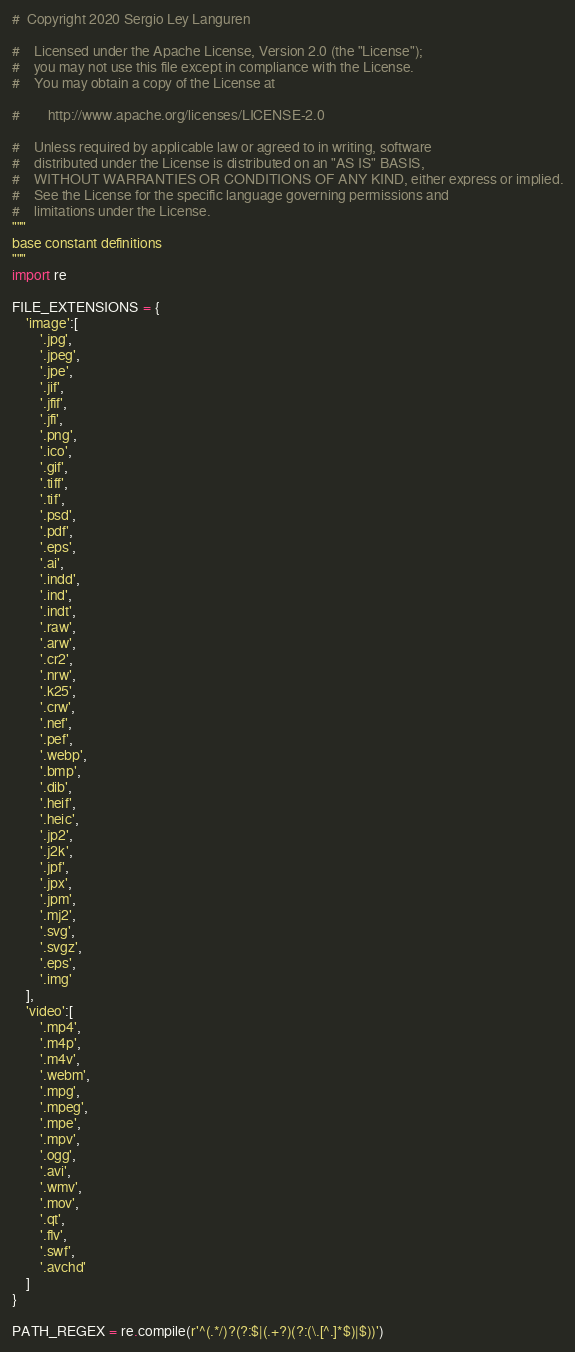<code> <loc_0><loc_0><loc_500><loc_500><_Python_>#  Copyright 2020 Sergio Ley Languren

#    Licensed under the Apache License, Version 2.0 (the "License");
#    you may not use this file except in compliance with the License.
#    You may obtain a copy of the License at

#        http://www.apache.org/licenses/LICENSE-2.0

#    Unless required by applicable law or agreed to in writing, software
#    distributed under the License is distributed on an "AS IS" BASIS,
#    WITHOUT WARRANTIES OR CONDITIONS OF ANY KIND, either express or implied.
#    See the License for the specific language governing permissions and
#    limitations under the License.
"""
base constant definitions
"""
import re

FILE_EXTENSIONS = {
    'image':[
        '.jpg',
        '.jpeg',
        '.jpe',
        '.jif',
        '.jfif',
        '.jfi',
        '.png',
        '.ico',
        '.gif',
        '.tiff',
        '.tif',
        '.psd',
        '.pdf',
        '.eps',
        '.ai',
        '.indd',
        '.ind',
        '.indt',
        '.raw',
        '.arw',
        '.cr2',
        '.nrw',
        '.k25',
        '.crw',
        '.nef',
        '.pef',
        '.webp',
        '.bmp',
        '.dib',
        '.heif',
        '.heic',
        '.jp2',
        '.j2k',
        '.jpf',
        '.jpx',
        '.jpm',
        '.mj2',
        '.svg',
        '.svgz',
        '.eps',
        '.img'
    ],
    'video':[
        '.mp4',
        '.m4p',
        '.m4v',
        '.webm',
        '.mpg',
        '.mpeg',
        '.mpe',
        '.mpv',
        '.ogg',
        '.avi',
        '.wmv',
        '.mov',
        '.qt',
        '.flv',
        '.swf',
        '.avchd'
    ]
}

PATH_REGEX = re.compile(r'^(.*/)?(?:$|(.+?)(?:(\.[^.]*$)|$))')</code> 